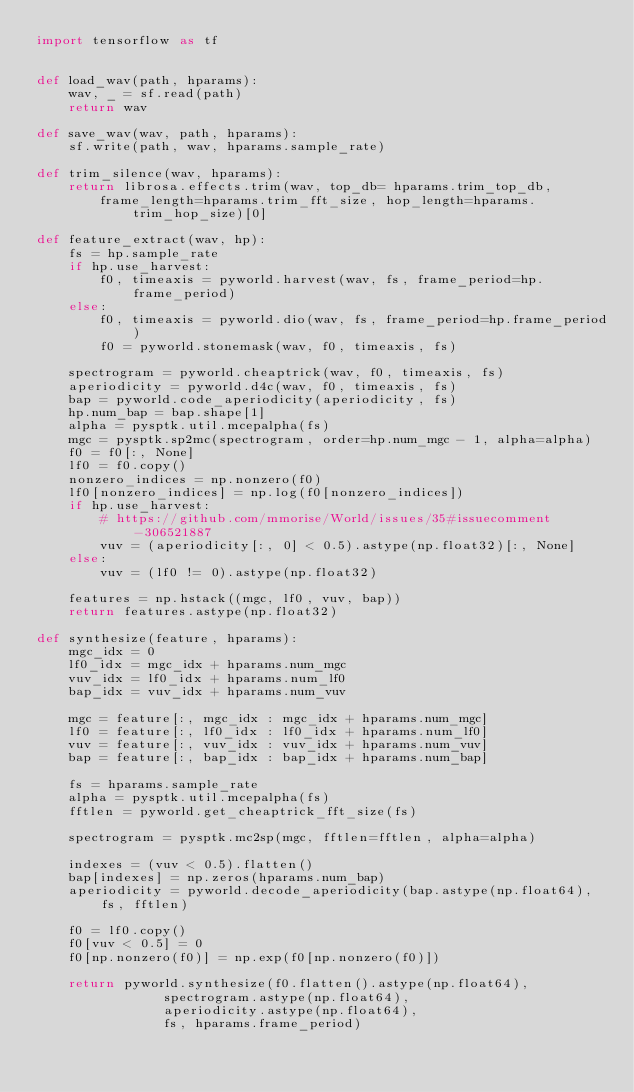Convert code to text. <code><loc_0><loc_0><loc_500><loc_500><_Python_>import tensorflow as tf


def load_wav(path, hparams):
	wav, _ = sf.read(path)
	return wav

def save_wav(wav, path, hparams):
	sf.write(path, wav, hparams.sample_rate)

def trim_silence(wav, hparams):
	return librosa.effects.trim(wav, top_db= hparams.trim_top_db,
		frame_length=hparams.trim_fft_size, hop_length=hparams.trim_hop_size)[0]

def feature_extract(wav, hp):
	fs = hp.sample_rate
	if hp.use_harvest:
		f0, timeaxis = pyworld.harvest(wav, fs, frame_period=hp.frame_period)
	else:
		f0, timeaxis = pyworld.dio(wav, fs, frame_period=hp.frame_period)
		f0 = pyworld.stonemask(wav, f0, timeaxis, fs)

	spectrogram = pyworld.cheaptrick(wav, f0, timeaxis, fs)
	aperiodicity = pyworld.d4c(wav, f0, timeaxis, fs)
	bap = pyworld.code_aperiodicity(aperiodicity, fs)
	hp.num_bap = bap.shape[1]
	alpha = pysptk.util.mcepalpha(fs)
	mgc = pysptk.sp2mc(spectrogram, order=hp.num_mgc - 1, alpha=alpha)
	f0 = f0[:, None]
	lf0 = f0.copy()
	nonzero_indices = np.nonzero(f0)
	lf0[nonzero_indices] = np.log(f0[nonzero_indices])
	if hp.use_harvest:
		# https://github.com/mmorise/World/issues/35#issuecomment-306521887
		vuv = (aperiodicity[:, 0] < 0.5).astype(np.float32)[:, None]
	else:
		vuv = (lf0 != 0).astype(np.float32)

	features = np.hstack((mgc, lf0, vuv, bap))
	return features.astype(np.float32)

def synthesize(feature, hparams):
	mgc_idx = 0
	lf0_idx = mgc_idx + hparams.num_mgc
	vuv_idx = lf0_idx + hparams.num_lf0
	bap_idx = vuv_idx + hparams.num_vuv

	mgc = feature[:, mgc_idx : mgc_idx + hparams.num_mgc]
	lf0 = feature[:, lf0_idx : lf0_idx + hparams.num_lf0]
	vuv = feature[:, vuv_idx : vuv_idx + hparams.num_vuv]
	bap = feature[:, bap_idx : bap_idx + hparams.num_bap]

	fs = hparams.sample_rate
	alpha = pysptk.util.mcepalpha(fs)
	fftlen = pyworld.get_cheaptrick_fft_size(fs)

	spectrogram = pysptk.mc2sp(mgc, fftlen=fftlen, alpha=alpha)

	indexes = (vuv < 0.5).flatten()
	bap[indexes] = np.zeros(hparams.num_bap)
	aperiodicity = pyworld.decode_aperiodicity(bap.astype(np.float64), fs, fftlen)

	f0 = lf0.copy()
	f0[vuv < 0.5] = 0
	f0[np.nonzero(f0)] = np.exp(f0[np.nonzero(f0)])

	return pyworld.synthesize(f0.flatten().astype(np.float64),
				spectrogram.astype(np.float64),
				aperiodicity.astype(np.float64),
				fs, hparams.frame_period)
</code> 